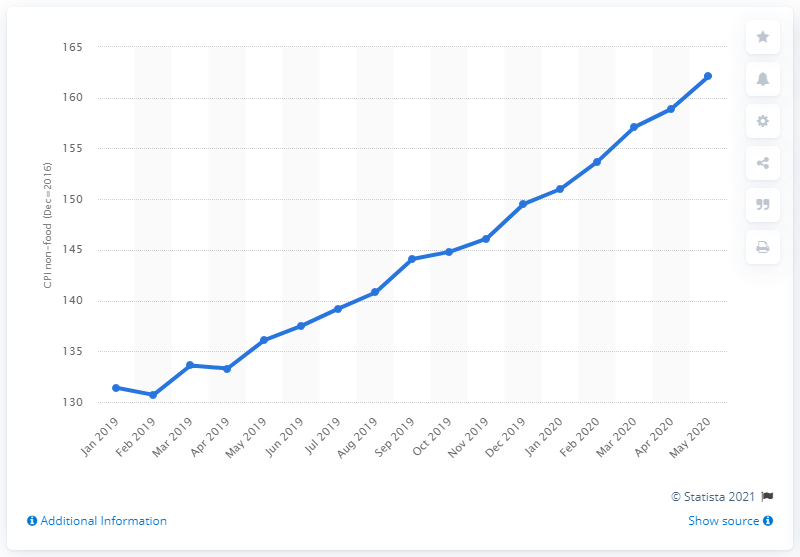Specify some key components in this picture. As of May 2020, the consumer price index for Ethiopia was 162.1. 